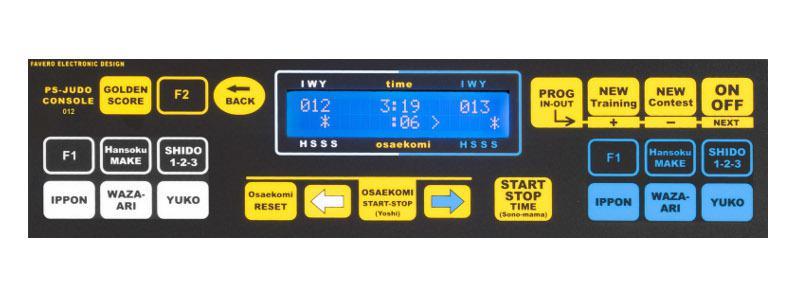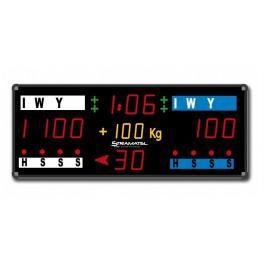The first image is the image on the left, the second image is the image on the right. Assess this claim about the two images: "One of the interfaces contains a weight category.". Correct or not? Answer yes or no. Yes. 